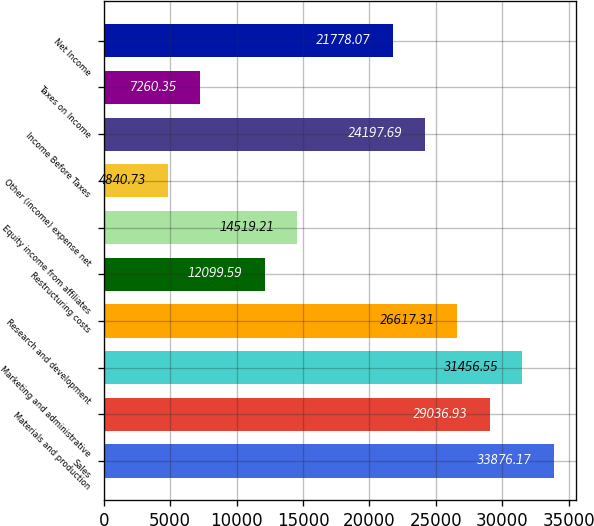Convert chart to OTSL. <chart><loc_0><loc_0><loc_500><loc_500><bar_chart><fcel>Sales<fcel>Materials and production<fcel>Marketing and administrative<fcel>Research and development<fcel>Restructuring costs<fcel>Equity income from affiliates<fcel>Other (income) expense net<fcel>Income Before Taxes<fcel>Taxes on Income<fcel>Net Income<nl><fcel>33876.2<fcel>29036.9<fcel>31456.5<fcel>26617.3<fcel>12099.6<fcel>14519.2<fcel>4840.73<fcel>24197.7<fcel>7260.35<fcel>21778.1<nl></chart> 